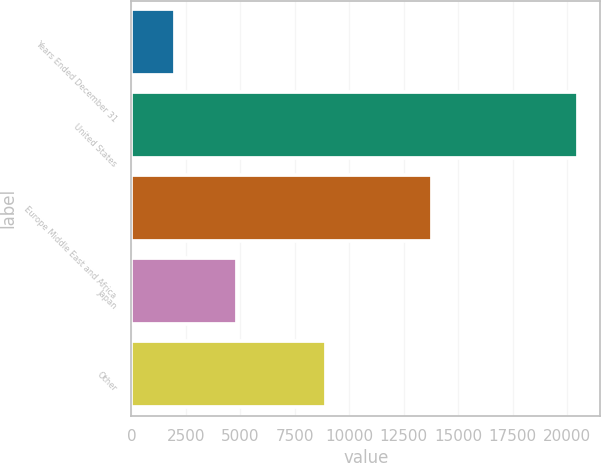<chart> <loc_0><loc_0><loc_500><loc_500><bar_chart><fcel>Years Ended December 31<fcel>United States<fcel>Europe Middle East and Africa<fcel>Japan<fcel>Other<nl><fcel>2011<fcel>20495<fcel>13782<fcel>4835<fcel>8935<nl></chart> 